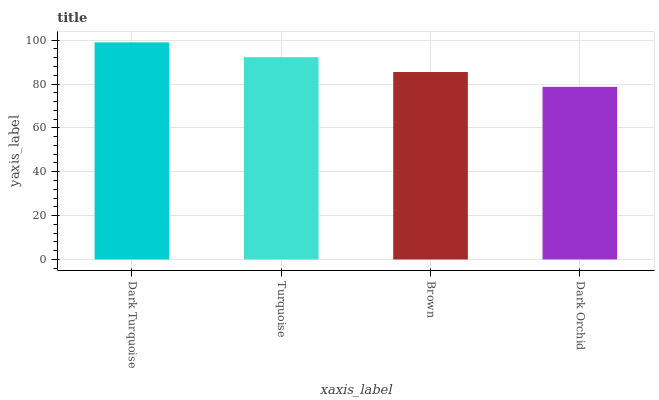Is Dark Orchid the minimum?
Answer yes or no. Yes. Is Dark Turquoise the maximum?
Answer yes or no. Yes. Is Turquoise the minimum?
Answer yes or no. No. Is Turquoise the maximum?
Answer yes or no. No. Is Dark Turquoise greater than Turquoise?
Answer yes or no. Yes. Is Turquoise less than Dark Turquoise?
Answer yes or no. Yes. Is Turquoise greater than Dark Turquoise?
Answer yes or no. No. Is Dark Turquoise less than Turquoise?
Answer yes or no. No. Is Turquoise the high median?
Answer yes or no. Yes. Is Brown the low median?
Answer yes or no. Yes. Is Dark Turquoise the high median?
Answer yes or no. No. Is Turquoise the low median?
Answer yes or no. No. 